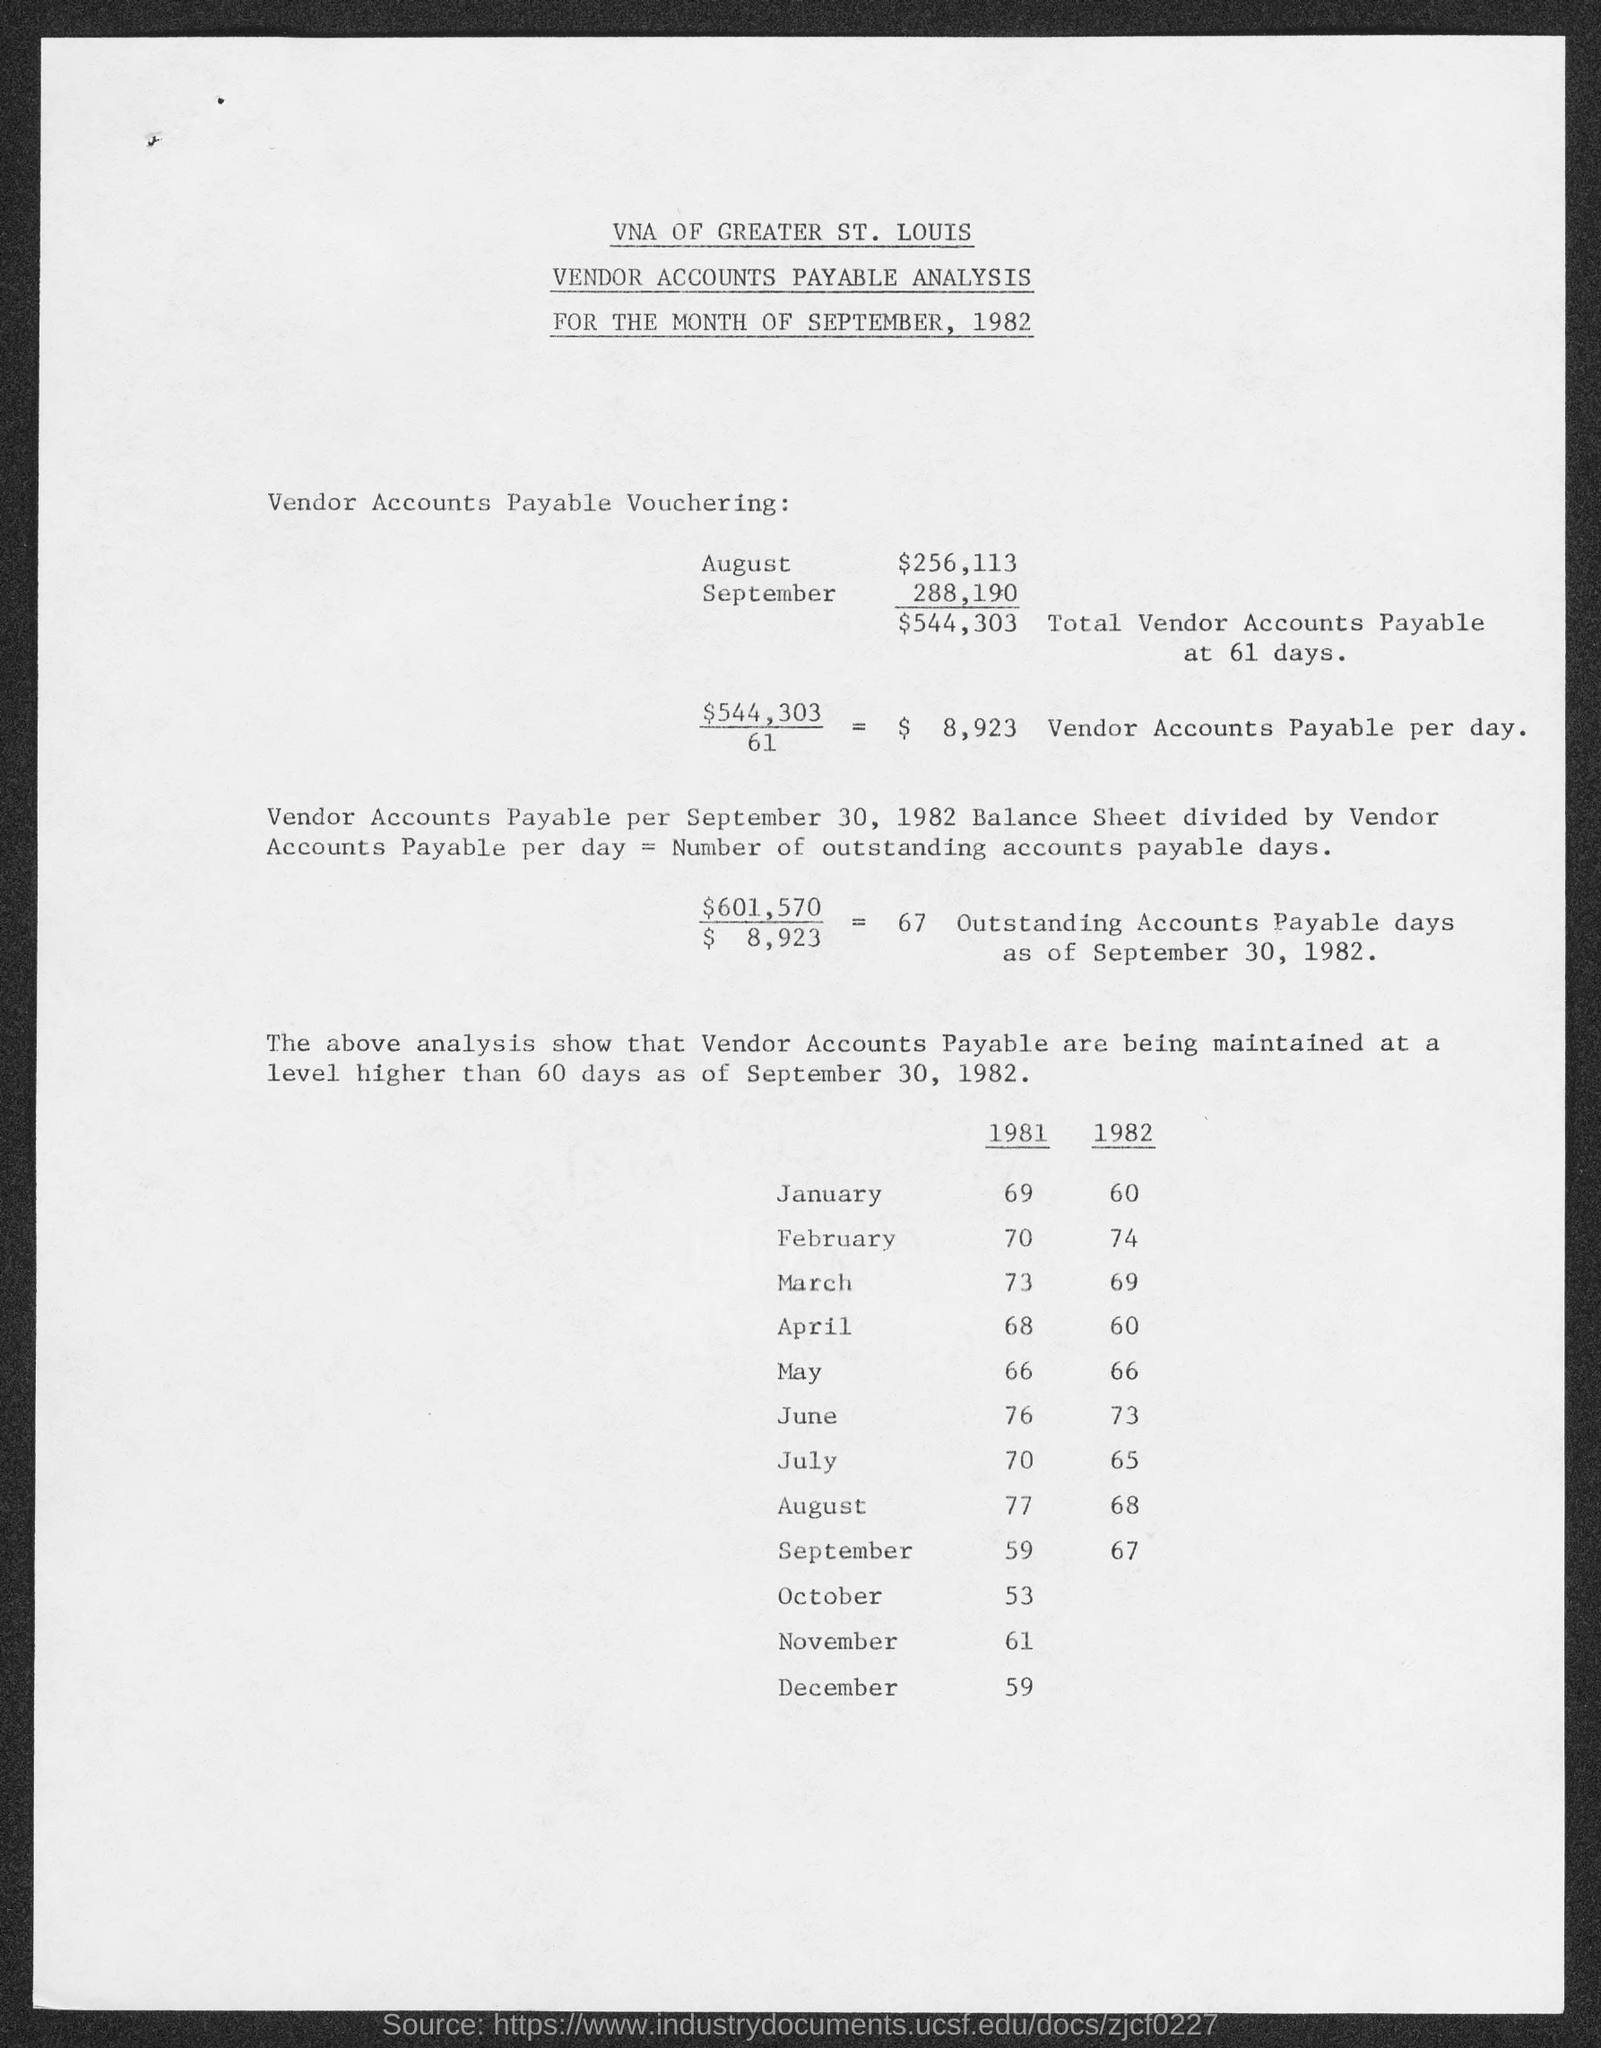Point out several critical features in this image. The total vendor accounts payable at 61 days, as mentioned on the given page, is $544,303. As of September 30, 1982, there were 67 outstanding accounts payable. The amount mentioned for September on the given page is 288,190. The amount mentioned for August on the given page is $256,113. The amount that vendor accounts payable is $8,923 per day, as mentioned in the provided page. 